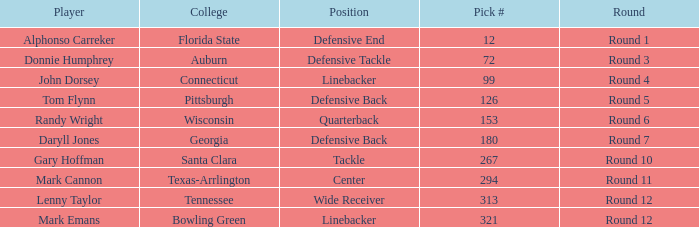In what Round was a player from College of Connecticut drafted? Round 4. 